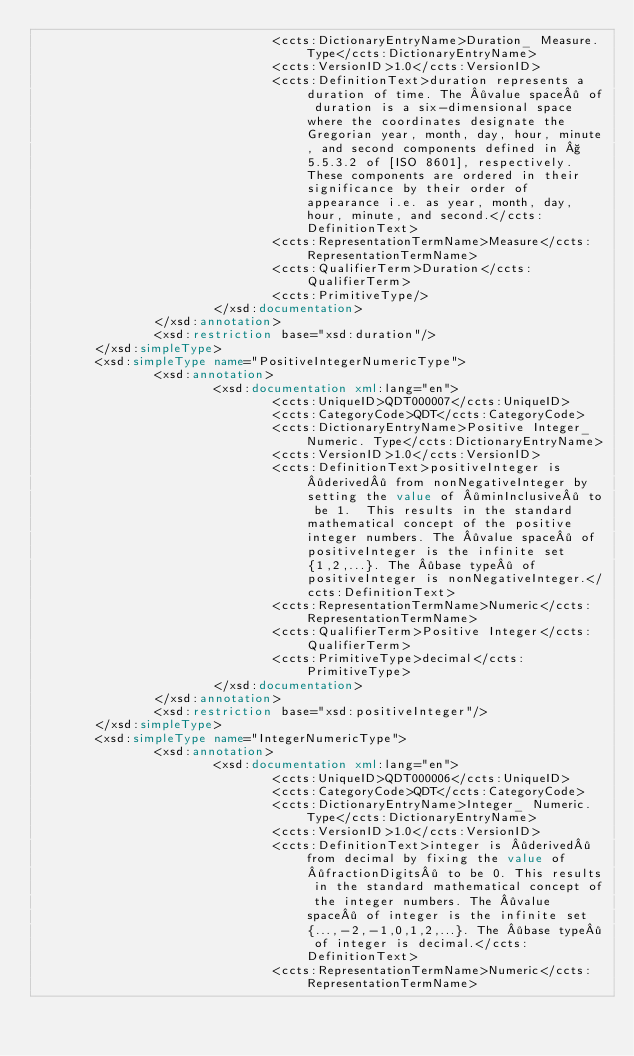<code> <loc_0><loc_0><loc_500><loc_500><_XML_>                                <ccts:DictionaryEntryName>Duration_ Measure. Type</ccts:DictionaryEntryName>
                                <ccts:VersionID>1.0</ccts:VersionID>
                                <ccts:DefinitionText>duration represents a duration of time. The ·value space· of duration is a six-dimensional space where the coordinates designate the Gregorian year, month, day, hour, minute, and second components defined in § 5.5.3.2 of [ISO 8601], respectively. These components are ordered in their significance by their order of appearance i.e. as year, month, day, hour, minute, and second.</ccts:DefinitionText>
                                <ccts:RepresentationTermName>Measure</ccts:RepresentationTermName>
                                <ccts:QualifierTerm>Duration</ccts:QualifierTerm>
                                <ccts:PrimitiveType/>
                        </xsd:documentation>
                </xsd:annotation>
                <xsd:restriction base="xsd:duration"/>
        </xsd:simpleType>
        <xsd:simpleType name="PositiveIntegerNumericType">
                <xsd:annotation>
                        <xsd:documentation xml:lang="en">
                                <ccts:UniqueID>QDT000007</ccts:UniqueID>
                                <ccts:CategoryCode>QDT</ccts:CategoryCode>
                                <ccts:DictionaryEntryName>Positive Integer_ Numeric. Type</ccts:DictionaryEntryName>
                                <ccts:VersionID>1.0</ccts:VersionID>
                                <ccts:DefinitionText>positiveInteger is ·derived· from nonNegativeInteger by setting the value of ·minInclusive· to be 1.  This results in the standard mathematical concept of the positive integer numbers. The ·value space· of positiveInteger is the infinite set {1,2,...}. The ·base type· of positiveInteger is nonNegativeInteger.</ccts:DefinitionText>
                                <ccts:RepresentationTermName>Numeric</ccts:RepresentationTermName>
                                <ccts:QualifierTerm>Positive Integer</ccts:QualifierTerm>
                                <ccts:PrimitiveType>decimal</ccts:PrimitiveType>
                        </xsd:documentation>
                </xsd:annotation>
                <xsd:restriction base="xsd:positiveInteger"/>
        </xsd:simpleType>
        <xsd:simpleType name="IntegerNumericType">
                <xsd:annotation>
                        <xsd:documentation xml:lang="en">
                                <ccts:UniqueID>QDT000006</ccts:UniqueID>
                                <ccts:CategoryCode>QDT</ccts:CategoryCode>
                                <ccts:DictionaryEntryName>Integer_ Numeric. Type</ccts:DictionaryEntryName>
                                <ccts:VersionID>1.0</ccts:VersionID>
                                <ccts:DefinitionText>integer is ·derived· from decimal by fixing the value of ·fractionDigits· to be 0. This results in the standard mathematical concept of the integer numbers. The ·value space· of integer is the infinite set {...,-2,-1,0,1,2,...}. The ·base type· of integer is decimal.</ccts:DefinitionText>
                                <ccts:RepresentationTermName>Numeric</ccts:RepresentationTermName></code> 